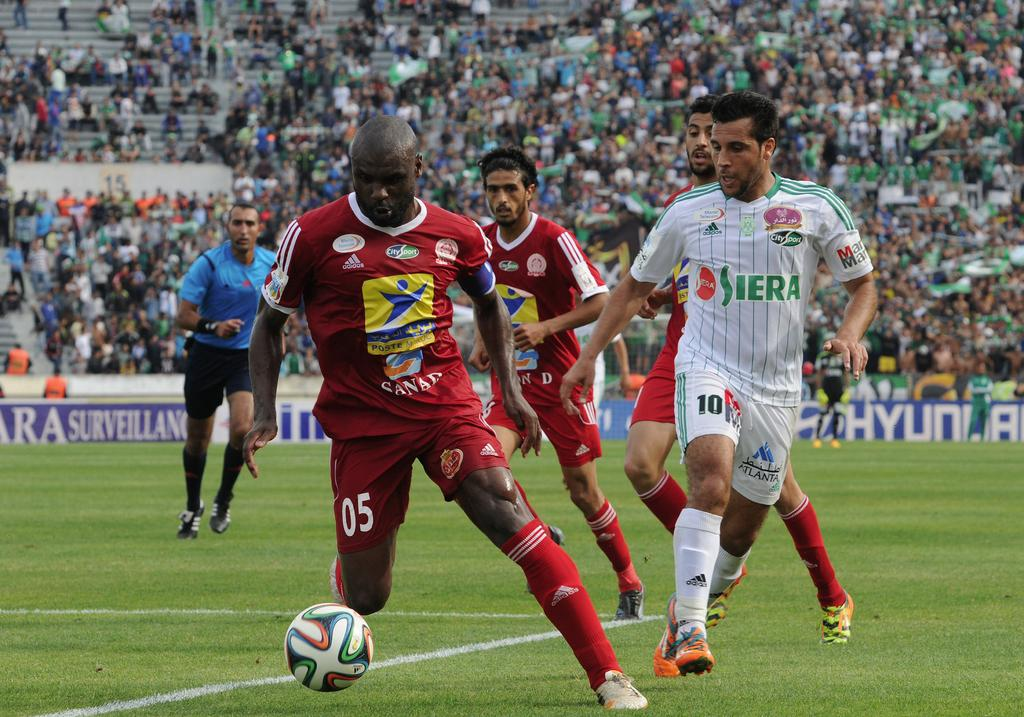<image>
Give a short and clear explanation of the subsequent image. The red-kitted 05 player is in full charge of the football at his soccer game. 